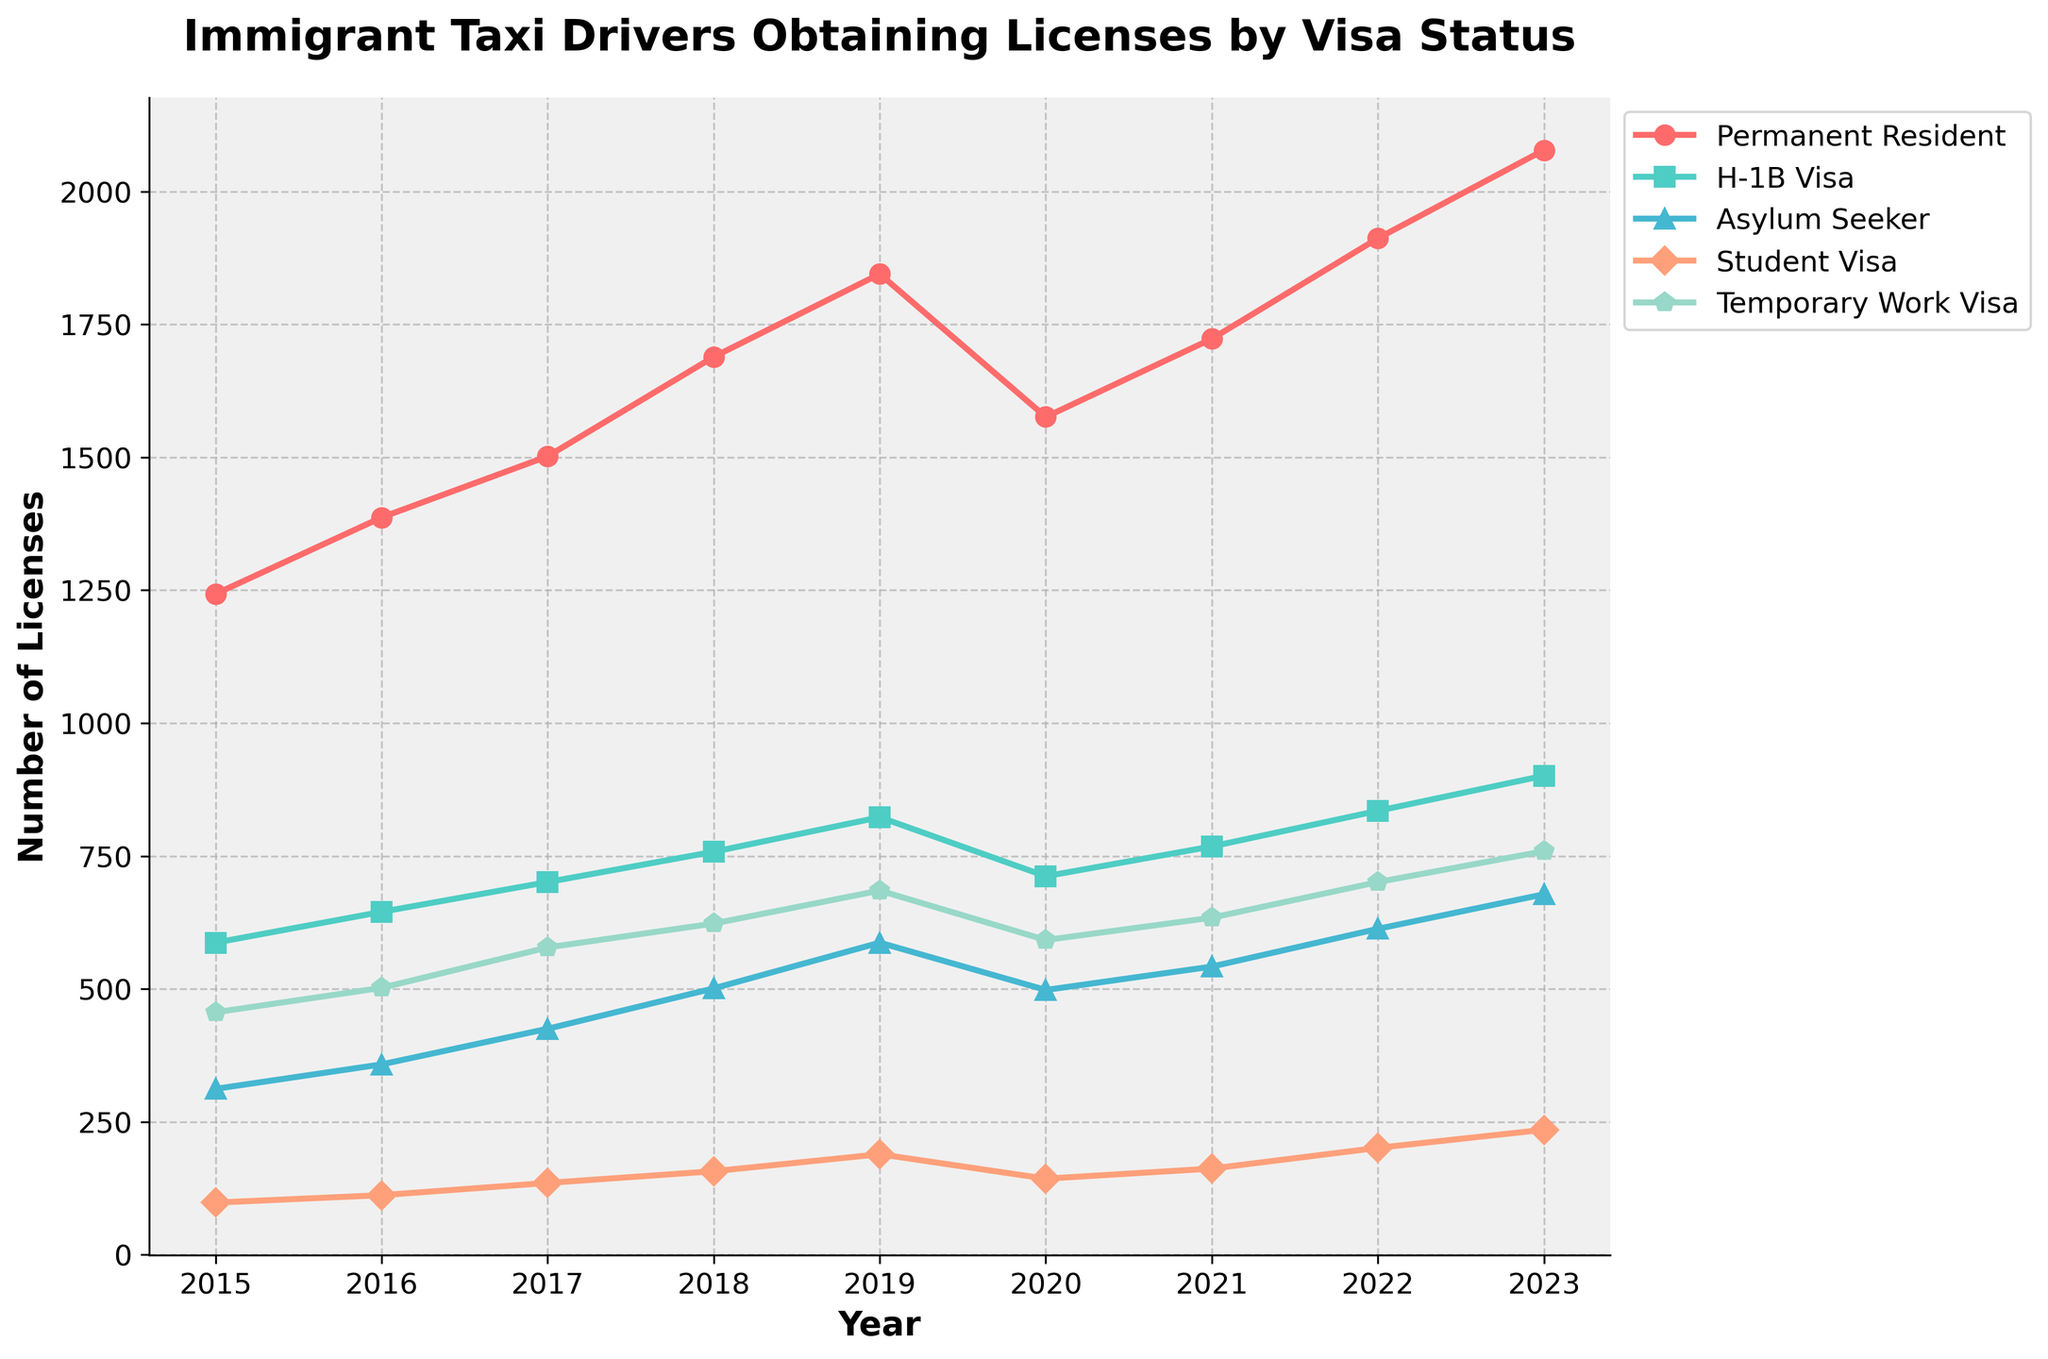Which visa status had the highest number of taxi drivers obtaining licenses in 2015? Look at the data points for the year 2015 across different visa categories. The "Permanent Resident" category has the highest value at 1243.
Answer: Permanent Resident How did the number of Student Visa holders obtaining licenses change from 2019 to 2020? Identify the values for Student Visa in 2019 and 2020. Calculate the difference: 143 (2020) - 189 (2019) = -46. There was a decrease of 46.
Answer: Decreased by 46 What was the average number of licenses obtained by Asylum Seekers from 2015 to 2023? Sum the numbers for Asylum Seekers from 2015 to 2023 and divide by the number of years. Calculation: (312 + 358 + 425 + 501 + 587 + 498 + 542 + 613 + 678) / 9 ≈ 501.
Answer: 501 Which visa category showed the most consistent yearly increase from 2015 to 2023? Determine the general trend in the data. "Permanent Resident" shows a consistent increase across all years.
Answer: Permanent Resident What was the total number of licenses obtained by Temporary Work Visa holders from 2015 to 2023? Sum the values for Temporary Work Visa from 2015 to 2023: (456 + 502 + 578 + 623 + 685 + 592 + 634 + 701 + 759) = 5530.
Answer: 5530 Compare the number of licenses obtained by H-1B Visa and Student Visa holders in 2022. Which is higher and by how much? Find the values for 2022: H-1B Visa (835), Student Visa (201). Calculate the difference: 835 - 201 = 634. H-1B Visa holders obtained more licenses by 634.
Answer: H-1B Visa, 634 more In which year did the number of Permanent Resident visa holders obtaining licenses surpass 2000? Look for the first year when Permanent Resident values exceed 2000. In 2023, they are at 2078.
Answer: 2023 What is the range in the number of licenses obtained by H-1B Visa holders from 2015 to 2023? Find the minimum and maximum values for H-1B Visa. Max: 901 (2023), Min: 587 (2015). Range = 901 - 587 = 314.
Answer: 314 Which year had the highest total number of licenses obtained across all visa statuses? Sum the values for each year and identify the highest sum. 2023 has the highest total sum of (2078 + 901 + 678 + 235 + 759) = 4651.
Answer: 2023 What is the difference between the number of licenses obtained by Asylum Seekers and Temporary Work Visa holders in 2021? Identify the values for 2021: Asylum Seeker (542), Temporary Work Visa (634). Difference = 634 - 542 = 92.
Answer: 92 